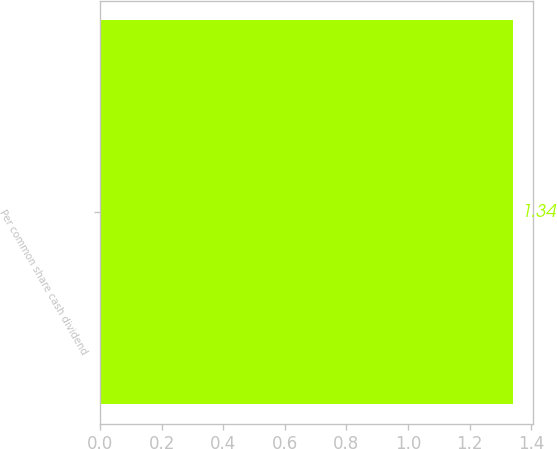Convert chart to OTSL. <chart><loc_0><loc_0><loc_500><loc_500><bar_chart><fcel>Per common share cash dividend<nl><fcel>1.34<nl></chart> 